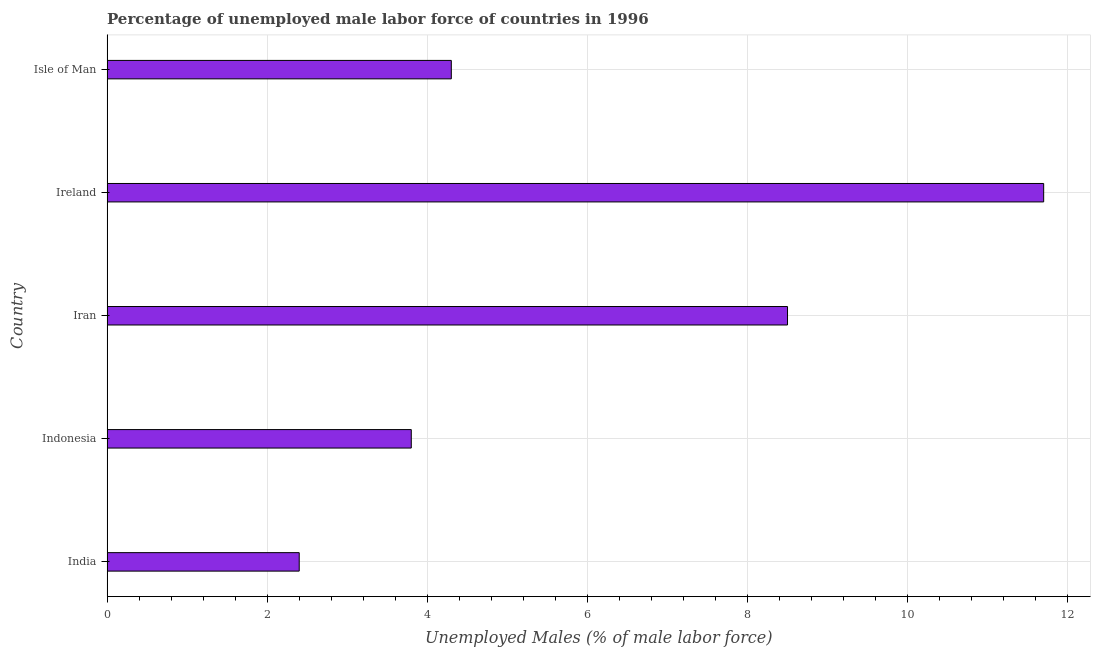What is the title of the graph?
Your answer should be very brief. Percentage of unemployed male labor force of countries in 1996. What is the label or title of the X-axis?
Your response must be concise. Unemployed Males (% of male labor force). What is the total unemployed male labour force in India?
Make the answer very short. 2.4. Across all countries, what is the maximum total unemployed male labour force?
Your response must be concise. 11.7. Across all countries, what is the minimum total unemployed male labour force?
Your answer should be compact. 2.4. In which country was the total unemployed male labour force maximum?
Your answer should be compact. Ireland. In which country was the total unemployed male labour force minimum?
Give a very brief answer. India. What is the sum of the total unemployed male labour force?
Provide a short and direct response. 30.7. What is the difference between the total unemployed male labour force in Iran and Ireland?
Ensure brevity in your answer.  -3.2. What is the average total unemployed male labour force per country?
Make the answer very short. 6.14. What is the median total unemployed male labour force?
Keep it short and to the point. 4.3. In how many countries, is the total unemployed male labour force greater than 1.6 %?
Keep it short and to the point. 5. What is the ratio of the total unemployed male labour force in Ireland to that in Isle of Man?
Offer a terse response. 2.72. Is the total unemployed male labour force in India less than that in Ireland?
Ensure brevity in your answer.  Yes. Is the difference between the total unemployed male labour force in India and Indonesia greater than the difference between any two countries?
Offer a terse response. No. What is the difference between the highest and the second highest total unemployed male labour force?
Offer a terse response. 3.2. What is the difference between the highest and the lowest total unemployed male labour force?
Your response must be concise. 9.3. In how many countries, is the total unemployed male labour force greater than the average total unemployed male labour force taken over all countries?
Make the answer very short. 2. Are all the bars in the graph horizontal?
Your answer should be compact. Yes. Are the values on the major ticks of X-axis written in scientific E-notation?
Your answer should be compact. No. What is the Unemployed Males (% of male labor force) of India?
Keep it short and to the point. 2.4. What is the Unemployed Males (% of male labor force) of Indonesia?
Provide a succinct answer. 3.8. What is the Unemployed Males (% of male labor force) in Iran?
Offer a very short reply. 8.5. What is the Unemployed Males (% of male labor force) in Ireland?
Give a very brief answer. 11.7. What is the Unemployed Males (% of male labor force) of Isle of Man?
Offer a terse response. 4.3. What is the difference between the Unemployed Males (% of male labor force) in India and Iran?
Offer a terse response. -6.1. What is the difference between the Unemployed Males (% of male labor force) in India and Isle of Man?
Your answer should be compact. -1.9. What is the difference between the Unemployed Males (% of male labor force) in Indonesia and Iran?
Offer a terse response. -4.7. What is the difference between the Unemployed Males (% of male labor force) in Indonesia and Ireland?
Your answer should be compact. -7.9. What is the difference between the Unemployed Males (% of male labor force) in Indonesia and Isle of Man?
Keep it short and to the point. -0.5. What is the difference between the Unemployed Males (% of male labor force) in Ireland and Isle of Man?
Ensure brevity in your answer.  7.4. What is the ratio of the Unemployed Males (% of male labor force) in India to that in Indonesia?
Provide a succinct answer. 0.63. What is the ratio of the Unemployed Males (% of male labor force) in India to that in Iran?
Offer a very short reply. 0.28. What is the ratio of the Unemployed Males (% of male labor force) in India to that in Ireland?
Make the answer very short. 0.2. What is the ratio of the Unemployed Males (% of male labor force) in India to that in Isle of Man?
Provide a succinct answer. 0.56. What is the ratio of the Unemployed Males (% of male labor force) in Indonesia to that in Iran?
Keep it short and to the point. 0.45. What is the ratio of the Unemployed Males (% of male labor force) in Indonesia to that in Ireland?
Give a very brief answer. 0.33. What is the ratio of the Unemployed Males (% of male labor force) in Indonesia to that in Isle of Man?
Offer a very short reply. 0.88. What is the ratio of the Unemployed Males (% of male labor force) in Iran to that in Ireland?
Offer a very short reply. 0.73. What is the ratio of the Unemployed Males (% of male labor force) in Iran to that in Isle of Man?
Provide a succinct answer. 1.98. What is the ratio of the Unemployed Males (% of male labor force) in Ireland to that in Isle of Man?
Give a very brief answer. 2.72. 